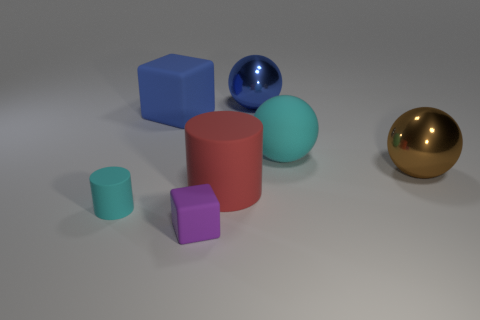Add 2 tiny purple rubber blocks. How many objects exist? 9 Subtract all large brown spheres. How many spheres are left? 2 Subtract 1 balls. How many balls are left? 2 Subtract all cyan cylinders. How many cylinders are left? 1 Subtract all cylinders. How many objects are left? 5 Subtract all red blocks. Subtract all brown spheres. How many blocks are left? 2 Subtract all big cylinders. Subtract all big gray shiny balls. How many objects are left? 6 Add 3 brown spheres. How many brown spheres are left? 4 Add 7 large rubber things. How many large rubber things exist? 10 Subtract 1 brown spheres. How many objects are left? 6 